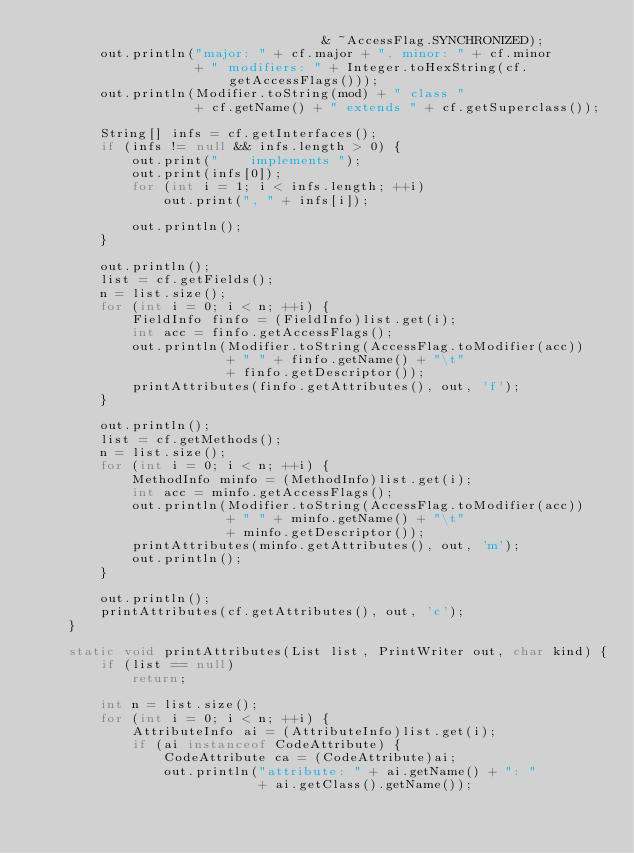Convert code to text. <code><loc_0><loc_0><loc_500><loc_500><_Java_>                                    & ~AccessFlag.SYNCHRONIZED);
        out.println("major: " + cf.major + ", minor: " + cf.minor
                    + " modifiers: " + Integer.toHexString(cf.getAccessFlags()));
        out.println(Modifier.toString(mod) + " class "
                    + cf.getName() + " extends " + cf.getSuperclass());

        String[] infs = cf.getInterfaces();
        if (infs != null && infs.length > 0) {
            out.print("    implements ");
            out.print(infs[0]);
            for (int i = 1; i < infs.length; ++i)
                out.print(", " + infs[i]);

            out.println();
        }

        out.println();
        list = cf.getFields();
        n = list.size();
        for (int i = 0; i < n; ++i) {
            FieldInfo finfo = (FieldInfo)list.get(i);
            int acc = finfo.getAccessFlags();
            out.println(Modifier.toString(AccessFlag.toModifier(acc))
                        + " " + finfo.getName() + "\t"
                        + finfo.getDescriptor());
            printAttributes(finfo.getAttributes(), out, 'f');
        }

        out.println();
        list = cf.getMethods();
        n = list.size();
        for (int i = 0; i < n; ++i) {
            MethodInfo minfo = (MethodInfo)list.get(i);
            int acc = minfo.getAccessFlags();
            out.println(Modifier.toString(AccessFlag.toModifier(acc))
                        + " " + minfo.getName() + "\t"
                        + minfo.getDescriptor());
            printAttributes(minfo.getAttributes(), out, 'm');
            out.println();
        }

        out.println();
        printAttributes(cf.getAttributes(), out, 'c');
    }

    static void printAttributes(List list, PrintWriter out, char kind) {
        if (list == null)
            return;

        int n = list.size();
        for (int i = 0; i < n; ++i) {
            AttributeInfo ai = (AttributeInfo)list.get(i);
            if (ai instanceof CodeAttribute) {
                CodeAttribute ca = (CodeAttribute)ai;
                out.println("attribute: " + ai.getName() + ": "
                            + ai.getClass().getName());</code> 